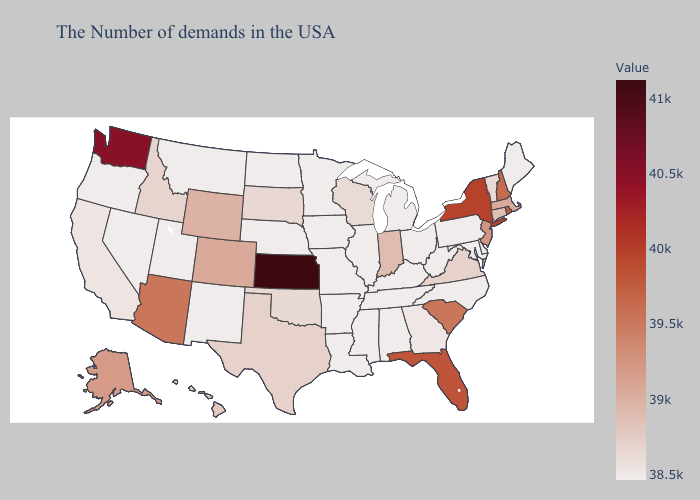Among the states that border Connecticut , does Massachusetts have the lowest value?
Concise answer only. Yes. Does the map have missing data?
Concise answer only. No. Among the states that border North Carolina , does Tennessee have the lowest value?
Write a very short answer. Yes. Does Mississippi have the lowest value in the South?
Be succinct. Yes. Which states hav the highest value in the Northeast?
Answer briefly. New York. Among the states that border North Carolina , which have the highest value?
Answer briefly. South Carolina. 